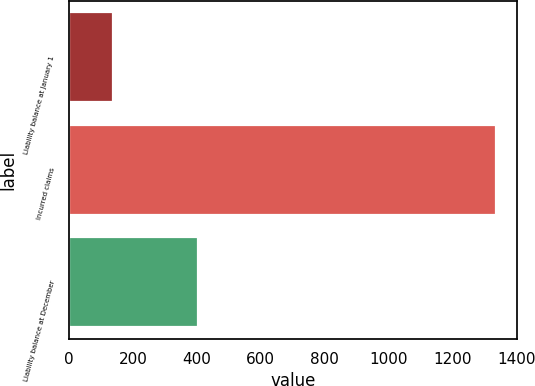Convert chart. <chart><loc_0><loc_0><loc_500><loc_500><bar_chart><fcel>Liability balance at January 1<fcel>Incurred claims<fcel>Liability balance at December<nl><fcel>136<fcel>1335<fcel>403<nl></chart> 